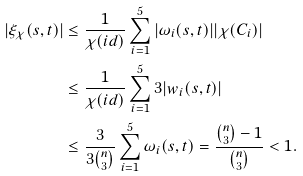<formula> <loc_0><loc_0><loc_500><loc_500>| \xi _ { \chi } ( s , t ) | & \leq \frac { 1 } { \chi ( i d ) } \sum _ { i = 1 } ^ { 5 } | \omega _ { i } ( s , t ) | | \chi ( C _ { i } ) | \\ & \leq \frac { 1 } { \chi ( i d ) } \sum _ { i = 1 } ^ { 5 } 3 | w _ { i } ( s , t ) | \\ & \leq \frac { 3 } { 3 \binom { n } { 3 } } \sum _ { i = 1 } ^ { 5 } \omega _ { i } ( s , t ) = \frac { \binom { n } { 3 } - 1 } { \binom { n } { 3 } } < 1 .</formula> 